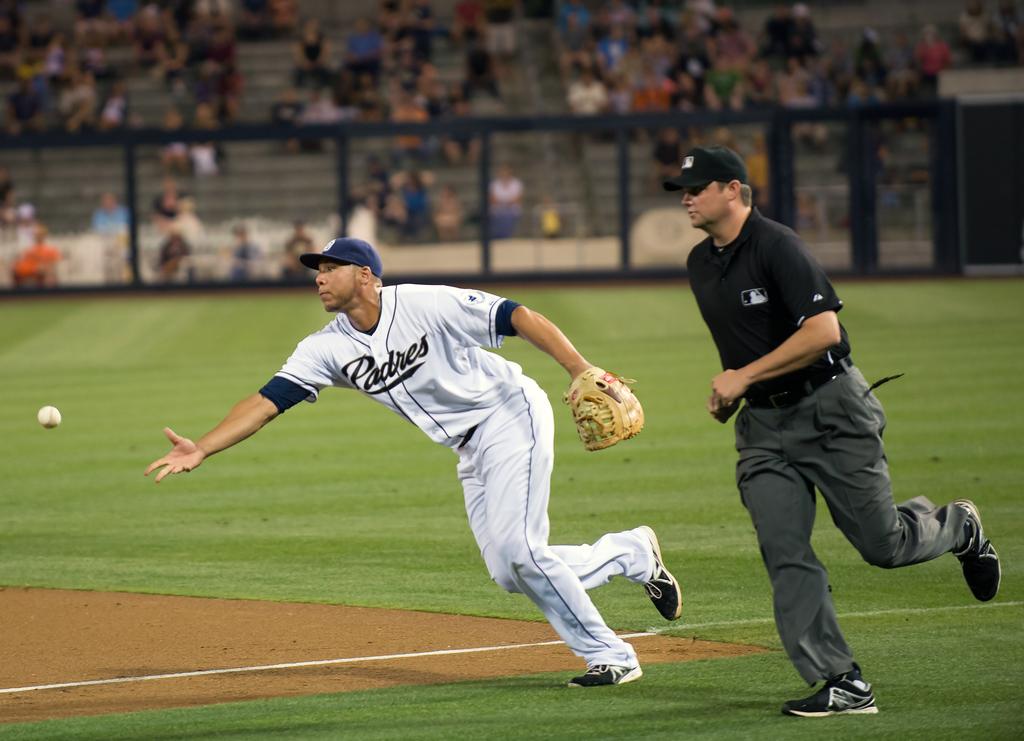What team does he play for?
Your answer should be compact. Padres. 